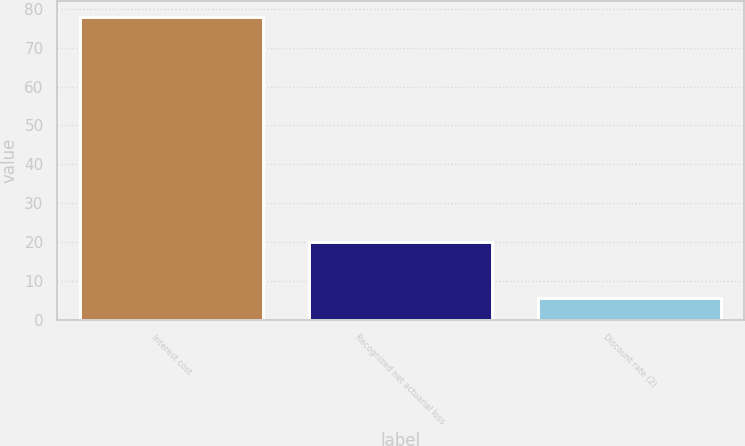<chart> <loc_0><loc_0><loc_500><loc_500><bar_chart><fcel>Interest cost<fcel>Recognized net actuarial loss<fcel>Discount rate (2)<nl><fcel>78<fcel>20<fcel>5.5<nl></chart> 